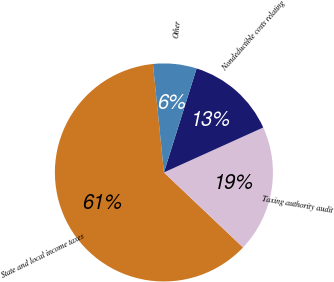Convert chart. <chart><loc_0><loc_0><loc_500><loc_500><pie_chart><fcel>State and local income taxes<fcel>Taxing authority audit<fcel>Nondeductible costs relating<fcel>Other<nl><fcel>61.32%<fcel>18.84%<fcel>13.39%<fcel>6.45%<nl></chart> 